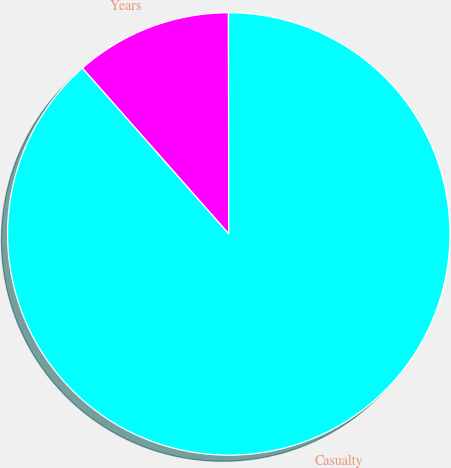Convert chart to OTSL. <chart><loc_0><loc_0><loc_500><loc_500><pie_chart><fcel>Years<fcel>Casualty<nl><fcel>11.49%<fcel>88.51%<nl></chart> 